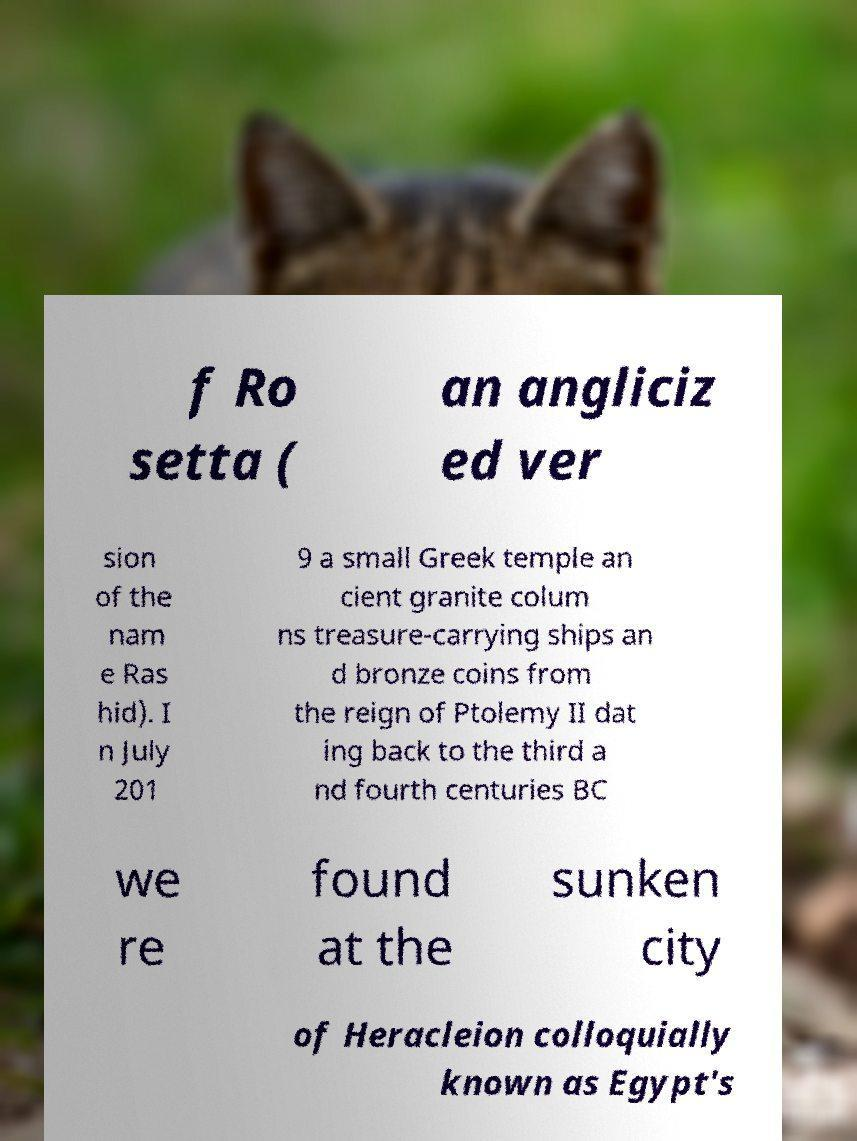Could you assist in decoding the text presented in this image and type it out clearly? f Ro setta ( an angliciz ed ver sion of the nam e Ras hid). I n July 201 9 a small Greek temple an cient granite colum ns treasure-carrying ships an d bronze coins from the reign of Ptolemy II dat ing back to the third a nd fourth centuries BC we re found at the sunken city of Heracleion colloquially known as Egypt's 